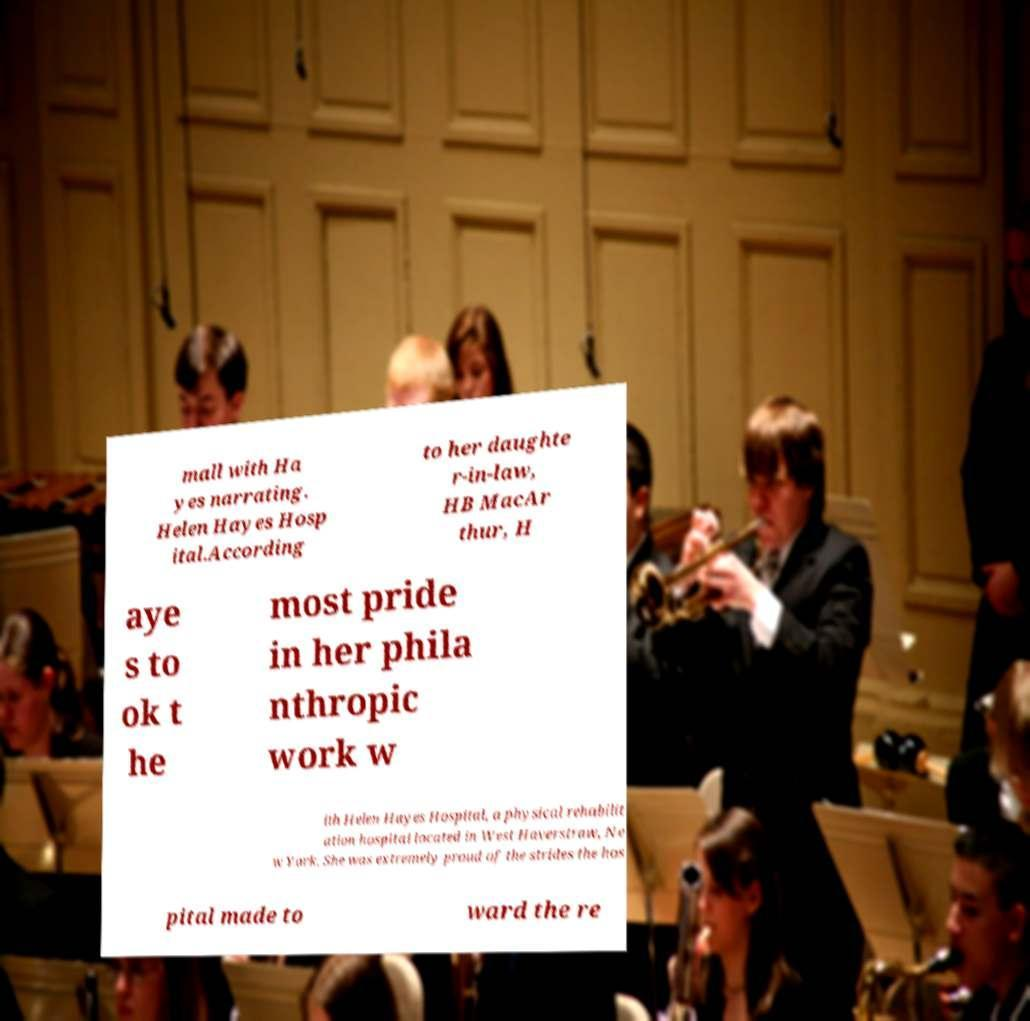Please read and relay the text visible in this image. What does it say? mall with Ha yes narrating. Helen Hayes Hosp ital.According to her daughte r-in-law, HB MacAr thur, H aye s to ok t he most pride in her phila nthropic work w ith Helen Hayes Hospital, a physical rehabilit ation hospital located in West Haverstraw, Ne w York. She was extremely proud of the strides the hos pital made to ward the re 